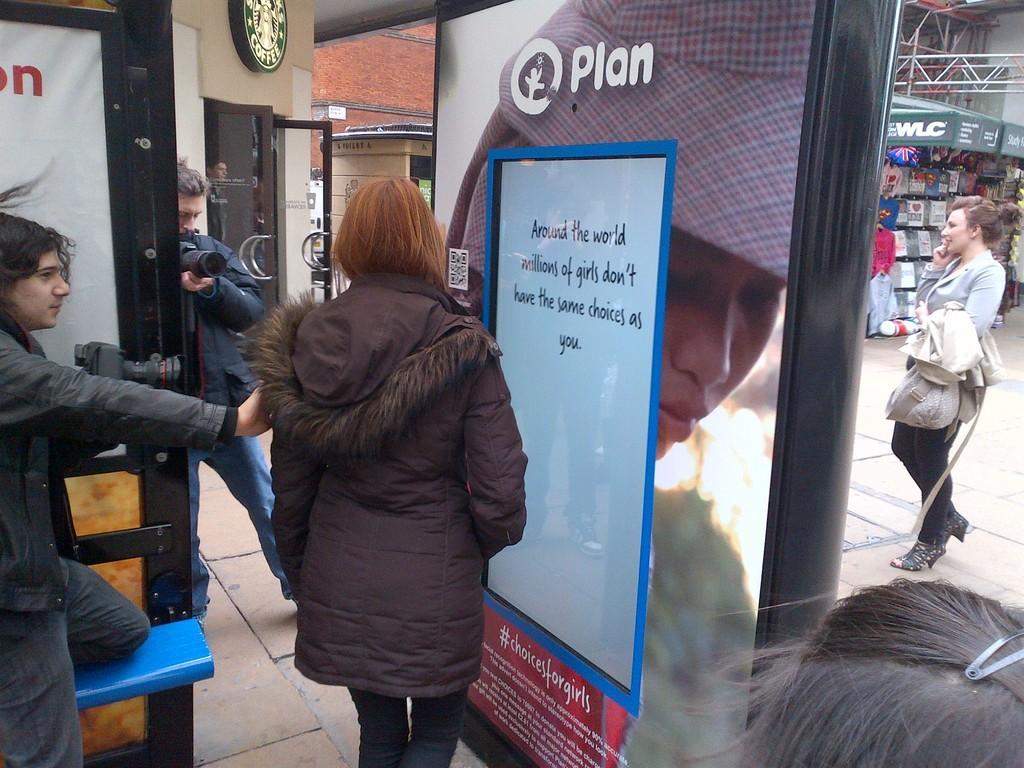In one or two sentences, can you explain what this image depicts? In this image I can see a group of people on the road, boards, wall, metal rods and shops. This image is taken during a day. 